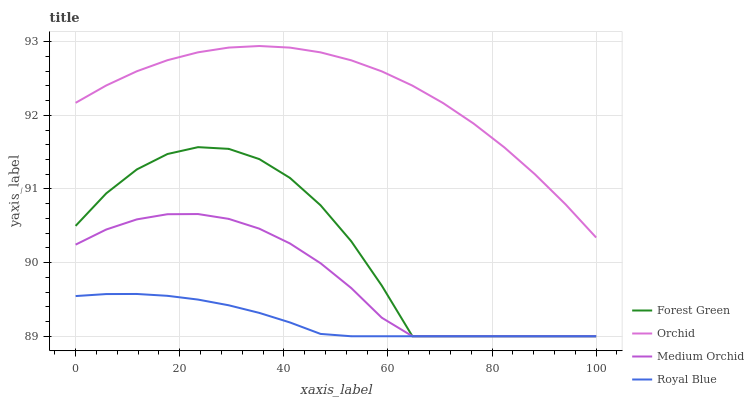Does Royal Blue have the minimum area under the curve?
Answer yes or no. Yes. Does Orchid have the maximum area under the curve?
Answer yes or no. Yes. Does Forest Green have the minimum area under the curve?
Answer yes or no. No. Does Forest Green have the maximum area under the curve?
Answer yes or no. No. Is Royal Blue the smoothest?
Answer yes or no. Yes. Is Forest Green the roughest?
Answer yes or no. Yes. Is Medium Orchid the smoothest?
Answer yes or no. No. Is Medium Orchid the roughest?
Answer yes or no. No. Does Royal Blue have the lowest value?
Answer yes or no. Yes. Does Orchid have the lowest value?
Answer yes or no. No. Does Orchid have the highest value?
Answer yes or no. Yes. Does Forest Green have the highest value?
Answer yes or no. No. Is Forest Green less than Orchid?
Answer yes or no. Yes. Is Orchid greater than Forest Green?
Answer yes or no. Yes. Does Forest Green intersect Medium Orchid?
Answer yes or no. Yes. Is Forest Green less than Medium Orchid?
Answer yes or no. No. Is Forest Green greater than Medium Orchid?
Answer yes or no. No. Does Forest Green intersect Orchid?
Answer yes or no. No. 